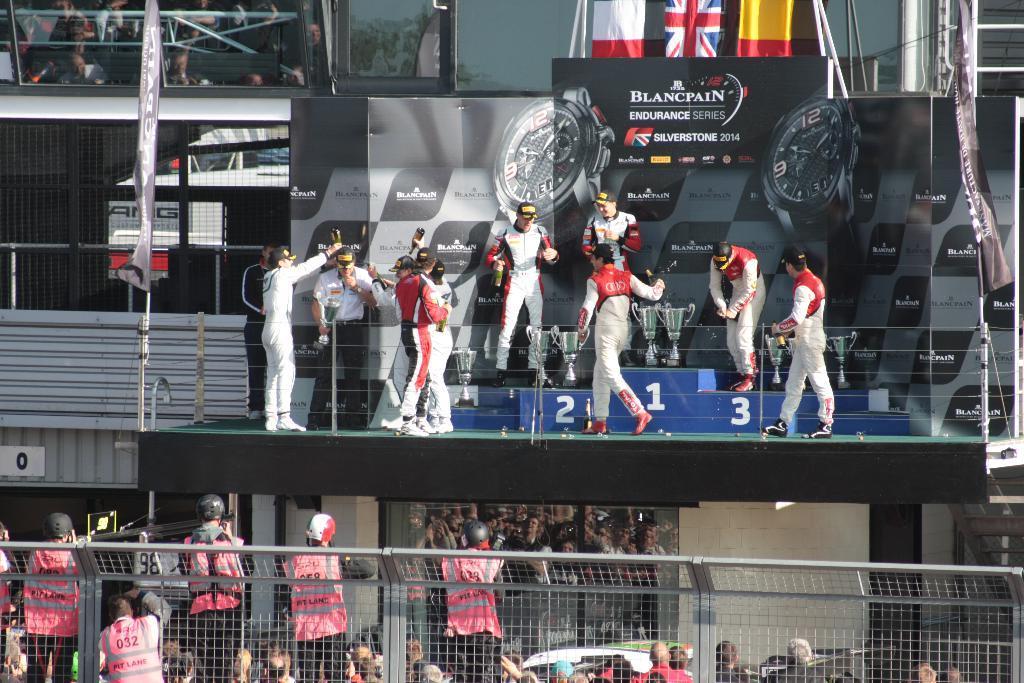How would you summarize this image in a sentence or two? In this image we can see group of people standing, some persons are holding bottles in their hands, one person is carrying a cup with his hands. Some persons wearing helmet and holding cameras. In the foreground we can see a fence, barricade. In the background, we can see the signboard with text, group of cups, building with windows, banner with text and group of flags. 